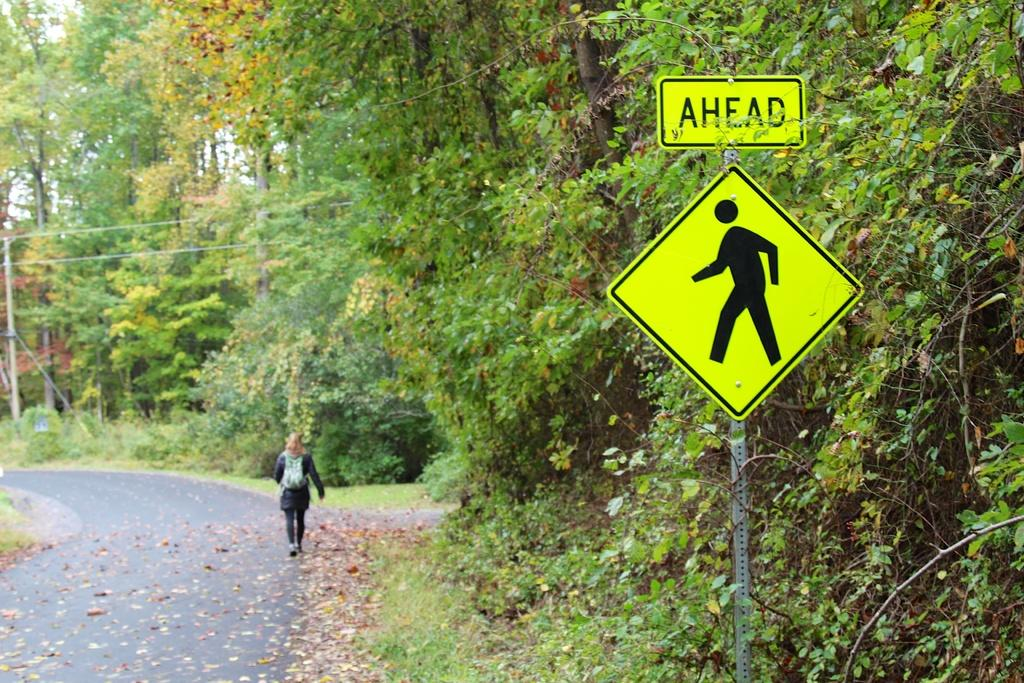Provide a one-sentence caption for the provided image. A woman is walking on the verge of a country road. In the foreground is a yellow sign with the word Ahead and the silhouette of a person walking. 